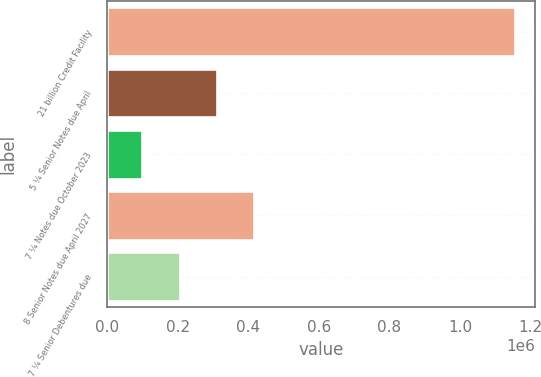Convert chart. <chart><loc_0><loc_0><loc_500><loc_500><bar_chart><fcel>21 billion Credit Facility<fcel>5 ¼ Senior Notes due April<fcel>7 ¼ Notes due October 2023<fcel>8 Senior Notes due April 2027<fcel>7 ¼ Senior Debentures due<nl><fcel>1.155e+06<fcel>311000<fcel>100000<fcel>416500<fcel>205500<nl></chart> 